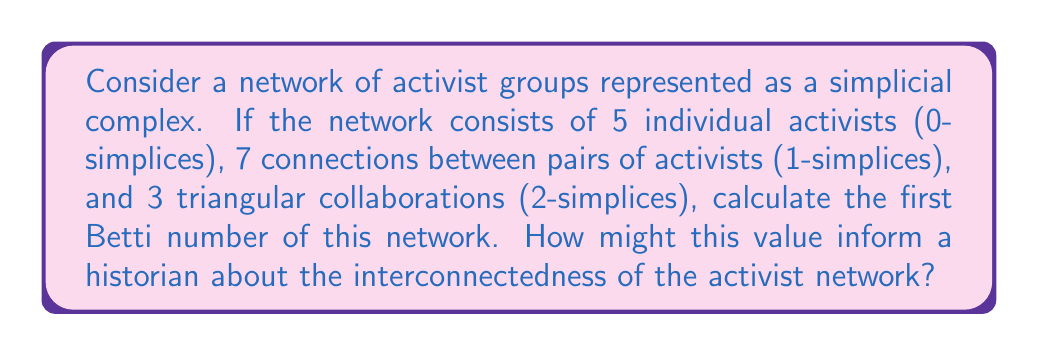Can you solve this math problem? To solve this problem, we'll use concepts from algebraic topology applied to social networks:

1) First, let's identify the components of our simplicial complex:
   - $f_0 = 5$ (0-simplices, individual activists)
   - $f_1 = 7$ (1-simplices, connections between pairs)
   - $f_2 = 3$ (2-simplices, triangular collaborations)

2) The Euler characteristic $\chi$ of the simplicial complex is given by:
   $$\chi = f_0 - f_1 + f_2$$

3) Substituting our values:
   $$\chi = 5 - 7 + 3 = 1$$

4) The Betti numbers $b_i$ are related to the Euler characteristic by:
   $$\chi = b_0 - b_1 + b_2$$

5) We know that $b_0$ represents the number of connected components. Since this is a network, we assume it's connected, so $b_0 = 1$.

6) We also know that $b_2 = 0$ for a 2-dimensional simplicial complex.

7) Substituting into the equation from step 4:
   $$1 = 1 - b_1 + 0$$

8) Solving for $b_1$:
   $$b_1 = 1 - 1 + 0 = 0$$

The first Betti number $b_1 = 0$ indicates that there are no cycles in the network that are not filled by higher-dimensional simplices. For a historian, this suggests a tightly interconnected activist network where most potential cycles of collaboration are realized as full group collaborations (triangles). This implies a high degree of cohesion and coordination among the activists in the network.
Answer: $b_1 = 0$ 